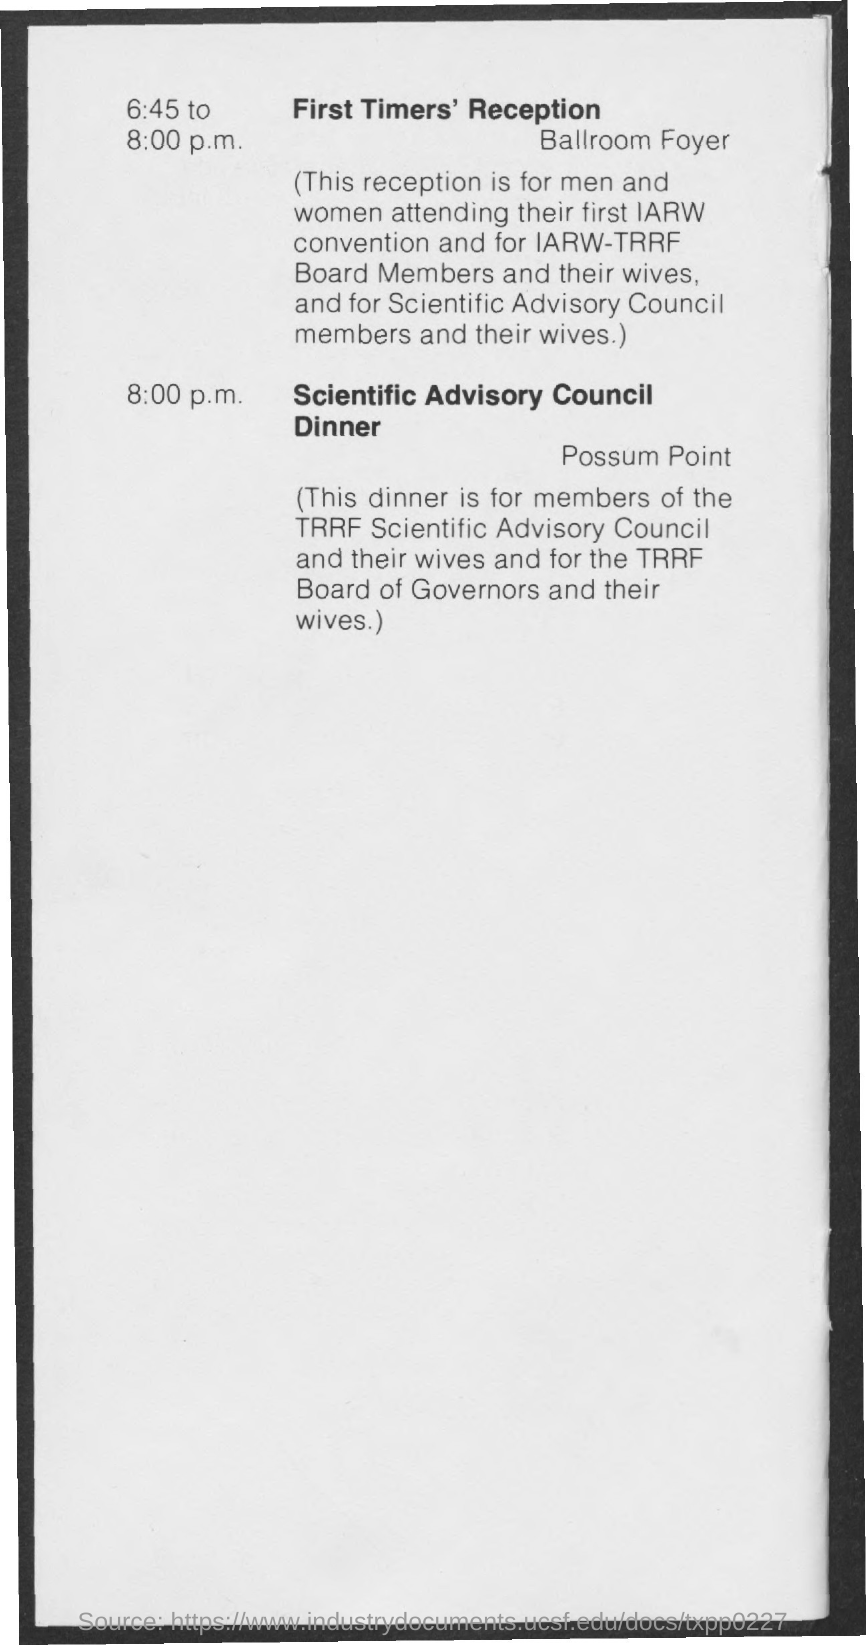"First Timers' Reception" is at what time?
Provide a short and direct response. 6.45 p.m. "First Timers' Reception" is held at which place?
Your answer should be very brief. Ballroom Foyer. "Scientific Advisory Council Dinner" is at what time?
Offer a terse response. 8:00 p.m. "Scientific Advisory Council Dinner" is at which place?
Offer a very short reply. Possum point. The dinner is for members of which "Advisory Council"?
Your answer should be compact. TRRF Scientific Advisory Council. 